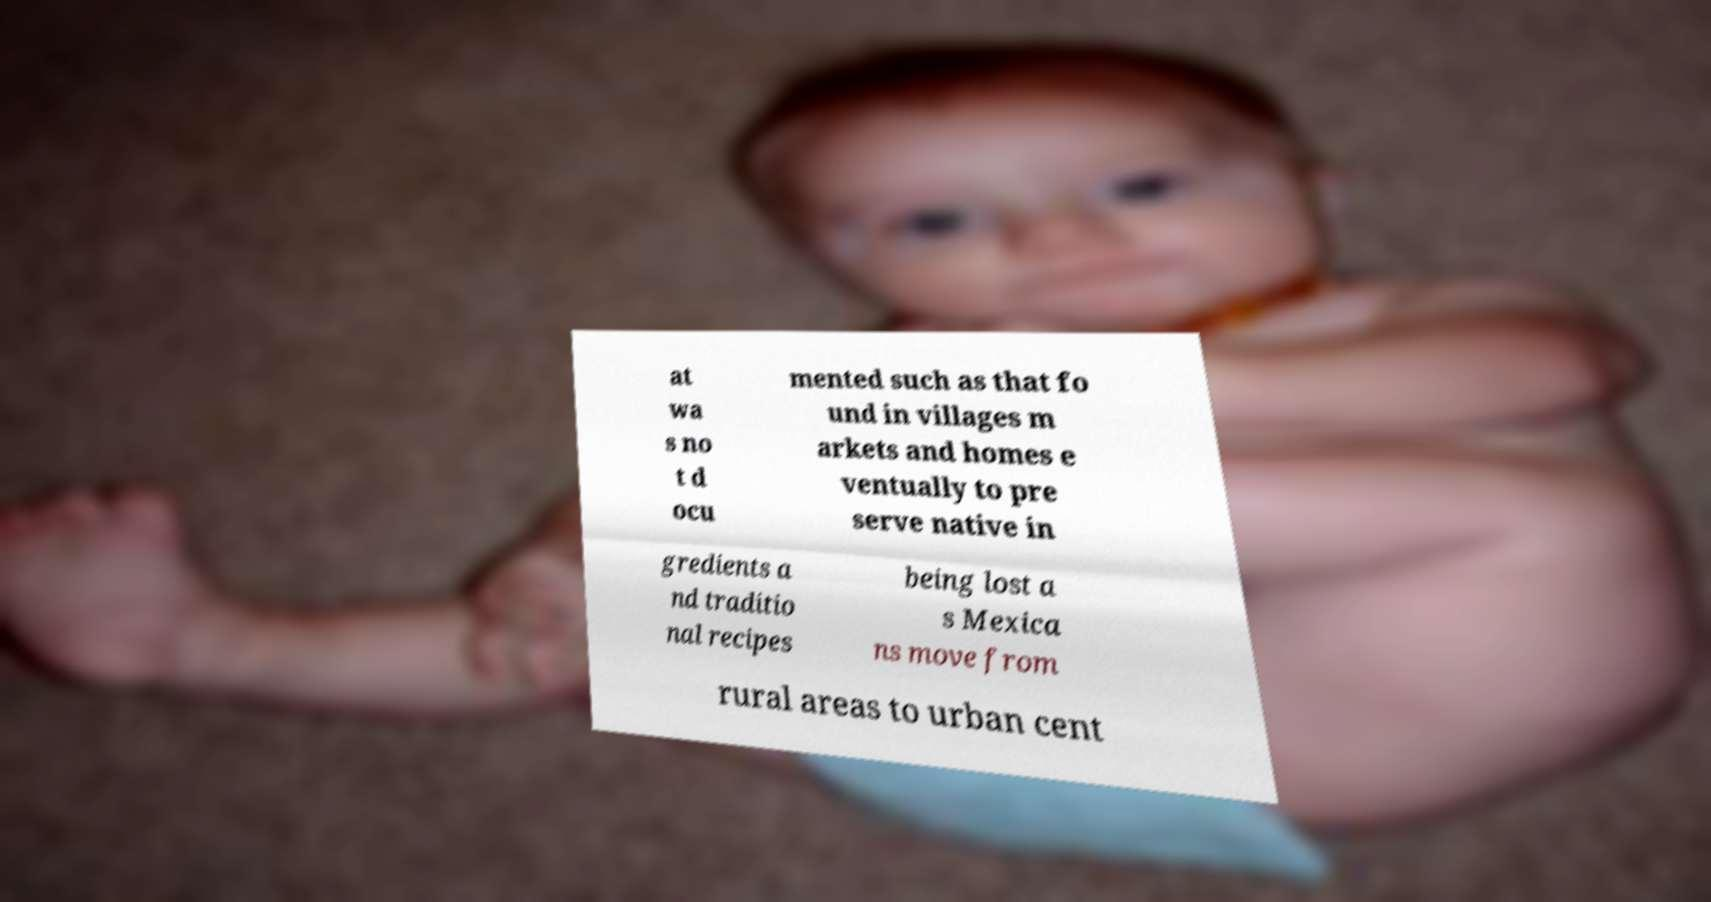Can you read and provide the text displayed in the image?This photo seems to have some interesting text. Can you extract and type it out for me? at wa s no t d ocu mented such as that fo und in villages m arkets and homes e ventually to pre serve native in gredients a nd traditio nal recipes being lost a s Mexica ns move from rural areas to urban cent 